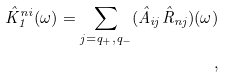Convert formula to latex. <formula><loc_0><loc_0><loc_500><loc_500>\hat { K } _ { 1 } ^ { n i } ( \omega ) = \sum _ { j = q _ { + } , q _ { - } } ( \hat { A } _ { i j } \hat { R } _ { n j } ) ( \omega ) \\ ,</formula> 